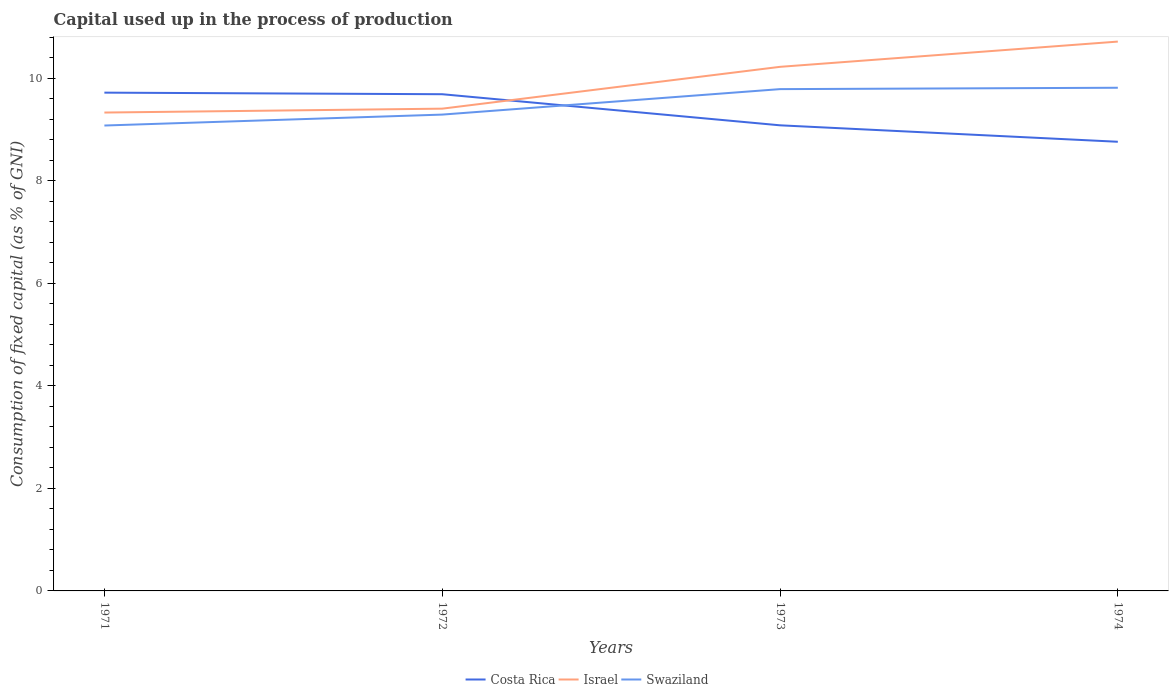How many different coloured lines are there?
Provide a succinct answer. 3. Does the line corresponding to Israel intersect with the line corresponding to Swaziland?
Give a very brief answer. No. Across all years, what is the maximum capital used up in the process of production in Swaziland?
Make the answer very short. 9.08. In which year was the capital used up in the process of production in Israel maximum?
Ensure brevity in your answer.  1971. What is the total capital used up in the process of production in Israel in the graph?
Provide a short and direct response. -0.49. What is the difference between the highest and the second highest capital used up in the process of production in Costa Rica?
Give a very brief answer. 0.96. Does the graph contain any zero values?
Give a very brief answer. No. Where does the legend appear in the graph?
Ensure brevity in your answer.  Bottom center. What is the title of the graph?
Your answer should be compact. Capital used up in the process of production. What is the label or title of the X-axis?
Make the answer very short. Years. What is the label or title of the Y-axis?
Keep it short and to the point. Consumption of fixed capital (as % of GNI). What is the Consumption of fixed capital (as % of GNI) in Costa Rica in 1971?
Make the answer very short. 9.72. What is the Consumption of fixed capital (as % of GNI) of Israel in 1971?
Offer a very short reply. 9.33. What is the Consumption of fixed capital (as % of GNI) of Swaziland in 1971?
Your response must be concise. 9.08. What is the Consumption of fixed capital (as % of GNI) of Costa Rica in 1972?
Your answer should be compact. 9.69. What is the Consumption of fixed capital (as % of GNI) of Israel in 1972?
Provide a short and direct response. 9.41. What is the Consumption of fixed capital (as % of GNI) of Swaziland in 1972?
Ensure brevity in your answer.  9.29. What is the Consumption of fixed capital (as % of GNI) of Costa Rica in 1973?
Your answer should be compact. 9.08. What is the Consumption of fixed capital (as % of GNI) in Israel in 1973?
Keep it short and to the point. 10.22. What is the Consumption of fixed capital (as % of GNI) in Swaziland in 1973?
Keep it short and to the point. 9.79. What is the Consumption of fixed capital (as % of GNI) of Costa Rica in 1974?
Offer a terse response. 8.76. What is the Consumption of fixed capital (as % of GNI) of Israel in 1974?
Give a very brief answer. 10.72. What is the Consumption of fixed capital (as % of GNI) in Swaziland in 1974?
Give a very brief answer. 9.82. Across all years, what is the maximum Consumption of fixed capital (as % of GNI) of Costa Rica?
Your answer should be compact. 9.72. Across all years, what is the maximum Consumption of fixed capital (as % of GNI) in Israel?
Your answer should be compact. 10.72. Across all years, what is the maximum Consumption of fixed capital (as % of GNI) of Swaziland?
Your response must be concise. 9.82. Across all years, what is the minimum Consumption of fixed capital (as % of GNI) in Costa Rica?
Provide a short and direct response. 8.76. Across all years, what is the minimum Consumption of fixed capital (as % of GNI) of Israel?
Your answer should be very brief. 9.33. Across all years, what is the minimum Consumption of fixed capital (as % of GNI) of Swaziland?
Ensure brevity in your answer.  9.08. What is the total Consumption of fixed capital (as % of GNI) of Costa Rica in the graph?
Provide a succinct answer. 37.25. What is the total Consumption of fixed capital (as % of GNI) in Israel in the graph?
Offer a terse response. 39.68. What is the total Consumption of fixed capital (as % of GNI) in Swaziland in the graph?
Your answer should be very brief. 37.97. What is the difference between the Consumption of fixed capital (as % of GNI) of Costa Rica in 1971 and that in 1972?
Provide a succinct answer. 0.03. What is the difference between the Consumption of fixed capital (as % of GNI) of Israel in 1971 and that in 1972?
Offer a very short reply. -0.08. What is the difference between the Consumption of fixed capital (as % of GNI) in Swaziland in 1971 and that in 1972?
Offer a terse response. -0.21. What is the difference between the Consumption of fixed capital (as % of GNI) of Costa Rica in 1971 and that in 1973?
Give a very brief answer. 0.64. What is the difference between the Consumption of fixed capital (as % of GNI) in Israel in 1971 and that in 1973?
Make the answer very short. -0.89. What is the difference between the Consumption of fixed capital (as % of GNI) in Swaziland in 1971 and that in 1973?
Your response must be concise. -0.71. What is the difference between the Consumption of fixed capital (as % of GNI) of Costa Rica in 1971 and that in 1974?
Your response must be concise. 0.96. What is the difference between the Consumption of fixed capital (as % of GNI) in Israel in 1971 and that in 1974?
Ensure brevity in your answer.  -1.38. What is the difference between the Consumption of fixed capital (as % of GNI) of Swaziland in 1971 and that in 1974?
Make the answer very short. -0.74. What is the difference between the Consumption of fixed capital (as % of GNI) of Costa Rica in 1972 and that in 1973?
Offer a terse response. 0.61. What is the difference between the Consumption of fixed capital (as % of GNI) in Israel in 1972 and that in 1973?
Ensure brevity in your answer.  -0.82. What is the difference between the Consumption of fixed capital (as % of GNI) in Swaziland in 1972 and that in 1973?
Offer a terse response. -0.5. What is the difference between the Consumption of fixed capital (as % of GNI) in Costa Rica in 1972 and that in 1974?
Provide a short and direct response. 0.93. What is the difference between the Consumption of fixed capital (as % of GNI) of Israel in 1972 and that in 1974?
Your response must be concise. -1.31. What is the difference between the Consumption of fixed capital (as % of GNI) in Swaziland in 1972 and that in 1974?
Keep it short and to the point. -0.52. What is the difference between the Consumption of fixed capital (as % of GNI) of Costa Rica in 1973 and that in 1974?
Keep it short and to the point. 0.32. What is the difference between the Consumption of fixed capital (as % of GNI) in Israel in 1973 and that in 1974?
Keep it short and to the point. -0.49. What is the difference between the Consumption of fixed capital (as % of GNI) in Swaziland in 1973 and that in 1974?
Your response must be concise. -0.03. What is the difference between the Consumption of fixed capital (as % of GNI) of Costa Rica in 1971 and the Consumption of fixed capital (as % of GNI) of Israel in 1972?
Your answer should be compact. 0.31. What is the difference between the Consumption of fixed capital (as % of GNI) in Costa Rica in 1971 and the Consumption of fixed capital (as % of GNI) in Swaziland in 1972?
Offer a terse response. 0.43. What is the difference between the Consumption of fixed capital (as % of GNI) in Israel in 1971 and the Consumption of fixed capital (as % of GNI) in Swaziland in 1972?
Provide a short and direct response. 0.04. What is the difference between the Consumption of fixed capital (as % of GNI) of Costa Rica in 1971 and the Consumption of fixed capital (as % of GNI) of Israel in 1973?
Ensure brevity in your answer.  -0.5. What is the difference between the Consumption of fixed capital (as % of GNI) of Costa Rica in 1971 and the Consumption of fixed capital (as % of GNI) of Swaziland in 1973?
Provide a short and direct response. -0.07. What is the difference between the Consumption of fixed capital (as % of GNI) of Israel in 1971 and the Consumption of fixed capital (as % of GNI) of Swaziland in 1973?
Make the answer very short. -0.46. What is the difference between the Consumption of fixed capital (as % of GNI) in Costa Rica in 1971 and the Consumption of fixed capital (as % of GNI) in Israel in 1974?
Keep it short and to the point. -1. What is the difference between the Consumption of fixed capital (as % of GNI) in Costa Rica in 1971 and the Consumption of fixed capital (as % of GNI) in Swaziland in 1974?
Give a very brief answer. -0.1. What is the difference between the Consumption of fixed capital (as % of GNI) in Israel in 1971 and the Consumption of fixed capital (as % of GNI) in Swaziland in 1974?
Provide a short and direct response. -0.48. What is the difference between the Consumption of fixed capital (as % of GNI) of Costa Rica in 1972 and the Consumption of fixed capital (as % of GNI) of Israel in 1973?
Offer a very short reply. -0.53. What is the difference between the Consumption of fixed capital (as % of GNI) in Costa Rica in 1972 and the Consumption of fixed capital (as % of GNI) in Swaziland in 1973?
Offer a terse response. -0.1. What is the difference between the Consumption of fixed capital (as % of GNI) in Israel in 1972 and the Consumption of fixed capital (as % of GNI) in Swaziland in 1973?
Provide a short and direct response. -0.38. What is the difference between the Consumption of fixed capital (as % of GNI) of Costa Rica in 1972 and the Consumption of fixed capital (as % of GNI) of Israel in 1974?
Keep it short and to the point. -1.03. What is the difference between the Consumption of fixed capital (as % of GNI) of Costa Rica in 1972 and the Consumption of fixed capital (as % of GNI) of Swaziland in 1974?
Give a very brief answer. -0.13. What is the difference between the Consumption of fixed capital (as % of GNI) in Israel in 1972 and the Consumption of fixed capital (as % of GNI) in Swaziland in 1974?
Provide a succinct answer. -0.41. What is the difference between the Consumption of fixed capital (as % of GNI) in Costa Rica in 1973 and the Consumption of fixed capital (as % of GNI) in Israel in 1974?
Ensure brevity in your answer.  -1.63. What is the difference between the Consumption of fixed capital (as % of GNI) of Costa Rica in 1973 and the Consumption of fixed capital (as % of GNI) of Swaziland in 1974?
Your answer should be very brief. -0.73. What is the difference between the Consumption of fixed capital (as % of GNI) of Israel in 1973 and the Consumption of fixed capital (as % of GNI) of Swaziland in 1974?
Give a very brief answer. 0.41. What is the average Consumption of fixed capital (as % of GNI) of Costa Rica per year?
Give a very brief answer. 9.31. What is the average Consumption of fixed capital (as % of GNI) in Israel per year?
Your answer should be compact. 9.92. What is the average Consumption of fixed capital (as % of GNI) in Swaziland per year?
Provide a succinct answer. 9.49. In the year 1971, what is the difference between the Consumption of fixed capital (as % of GNI) of Costa Rica and Consumption of fixed capital (as % of GNI) of Israel?
Keep it short and to the point. 0.39. In the year 1971, what is the difference between the Consumption of fixed capital (as % of GNI) in Costa Rica and Consumption of fixed capital (as % of GNI) in Swaziland?
Offer a very short reply. 0.64. In the year 1971, what is the difference between the Consumption of fixed capital (as % of GNI) of Israel and Consumption of fixed capital (as % of GNI) of Swaziland?
Make the answer very short. 0.25. In the year 1972, what is the difference between the Consumption of fixed capital (as % of GNI) in Costa Rica and Consumption of fixed capital (as % of GNI) in Israel?
Keep it short and to the point. 0.28. In the year 1972, what is the difference between the Consumption of fixed capital (as % of GNI) in Costa Rica and Consumption of fixed capital (as % of GNI) in Swaziland?
Provide a short and direct response. 0.4. In the year 1972, what is the difference between the Consumption of fixed capital (as % of GNI) of Israel and Consumption of fixed capital (as % of GNI) of Swaziland?
Make the answer very short. 0.12. In the year 1973, what is the difference between the Consumption of fixed capital (as % of GNI) of Costa Rica and Consumption of fixed capital (as % of GNI) of Israel?
Your answer should be compact. -1.14. In the year 1973, what is the difference between the Consumption of fixed capital (as % of GNI) in Costa Rica and Consumption of fixed capital (as % of GNI) in Swaziland?
Keep it short and to the point. -0.71. In the year 1973, what is the difference between the Consumption of fixed capital (as % of GNI) of Israel and Consumption of fixed capital (as % of GNI) of Swaziland?
Ensure brevity in your answer.  0.43. In the year 1974, what is the difference between the Consumption of fixed capital (as % of GNI) in Costa Rica and Consumption of fixed capital (as % of GNI) in Israel?
Your answer should be very brief. -1.95. In the year 1974, what is the difference between the Consumption of fixed capital (as % of GNI) in Costa Rica and Consumption of fixed capital (as % of GNI) in Swaziland?
Your response must be concise. -1.05. In the year 1974, what is the difference between the Consumption of fixed capital (as % of GNI) of Israel and Consumption of fixed capital (as % of GNI) of Swaziland?
Give a very brief answer. 0.9. What is the ratio of the Consumption of fixed capital (as % of GNI) in Swaziland in 1971 to that in 1972?
Keep it short and to the point. 0.98. What is the ratio of the Consumption of fixed capital (as % of GNI) in Costa Rica in 1971 to that in 1973?
Provide a short and direct response. 1.07. What is the ratio of the Consumption of fixed capital (as % of GNI) in Israel in 1971 to that in 1973?
Make the answer very short. 0.91. What is the ratio of the Consumption of fixed capital (as % of GNI) in Swaziland in 1971 to that in 1973?
Keep it short and to the point. 0.93. What is the ratio of the Consumption of fixed capital (as % of GNI) in Costa Rica in 1971 to that in 1974?
Offer a terse response. 1.11. What is the ratio of the Consumption of fixed capital (as % of GNI) in Israel in 1971 to that in 1974?
Your answer should be very brief. 0.87. What is the ratio of the Consumption of fixed capital (as % of GNI) in Swaziland in 1971 to that in 1974?
Keep it short and to the point. 0.92. What is the ratio of the Consumption of fixed capital (as % of GNI) of Costa Rica in 1972 to that in 1973?
Keep it short and to the point. 1.07. What is the ratio of the Consumption of fixed capital (as % of GNI) in Israel in 1972 to that in 1973?
Provide a short and direct response. 0.92. What is the ratio of the Consumption of fixed capital (as % of GNI) of Swaziland in 1972 to that in 1973?
Give a very brief answer. 0.95. What is the ratio of the Consumption of fixed capital (as % of GNI) in Costa Rica in 1972 to that in 1974?
Offer a terse response. 1.11. What is the ratio of the Consumption of fixed capital (as % of GNI) in Israel in 1972 to that in 1974?
Make the answer very short. 0.88. What is the ratio of the Consumption of fixed capital (as % of GNI) in Swaziland in 1972 to that in 1974?
Offer a very short reply. 0.95. What is the ratio of the Consumption of fixed capital (as % of GNI) in Costa Rica in 1973 to that in 1974?
Make the answer very short. 1.04. What is the ratio of the Consumption of fixed capital (as % of GNI) in Israel in 1973 to that in 1974?
Offer a very short reply. 0.95. What is the ratio of the Consumption of fixed capital (as % of GNI) in Swaziland in 1973 to that in 1974?
Provide a succinct answer. 1. What is the difference between the highest and the second highest Consumption of fixed capital (as % of GNI) in Costa Rica?
Your response must be concise. 0.03. What is the difference between the highest and the second highest Consumption of fixed capital (as % of GNI) of Israel?
Keep it short and to the point. 0.49. What is the difference between the highest and the second highest Consumption of fixed capital (as % of GNI) in Swaziland?
Make the answer very short. 0.03. What is the difference between the highest and the lowest Consumption of fixed capital (as % of GNI) in Costa Rica?
Provide a short and direct response. 0.96. What is the difference between the highest and the lowest Consumption of fixed capital (as % of GNI) of Israel?
Your answer should be compact. 1.38. What is the difference between the highest and the lowest Consumption of fixed capital (as % of GNI) in Swaziland?
Make the answer very short. 0.74. 